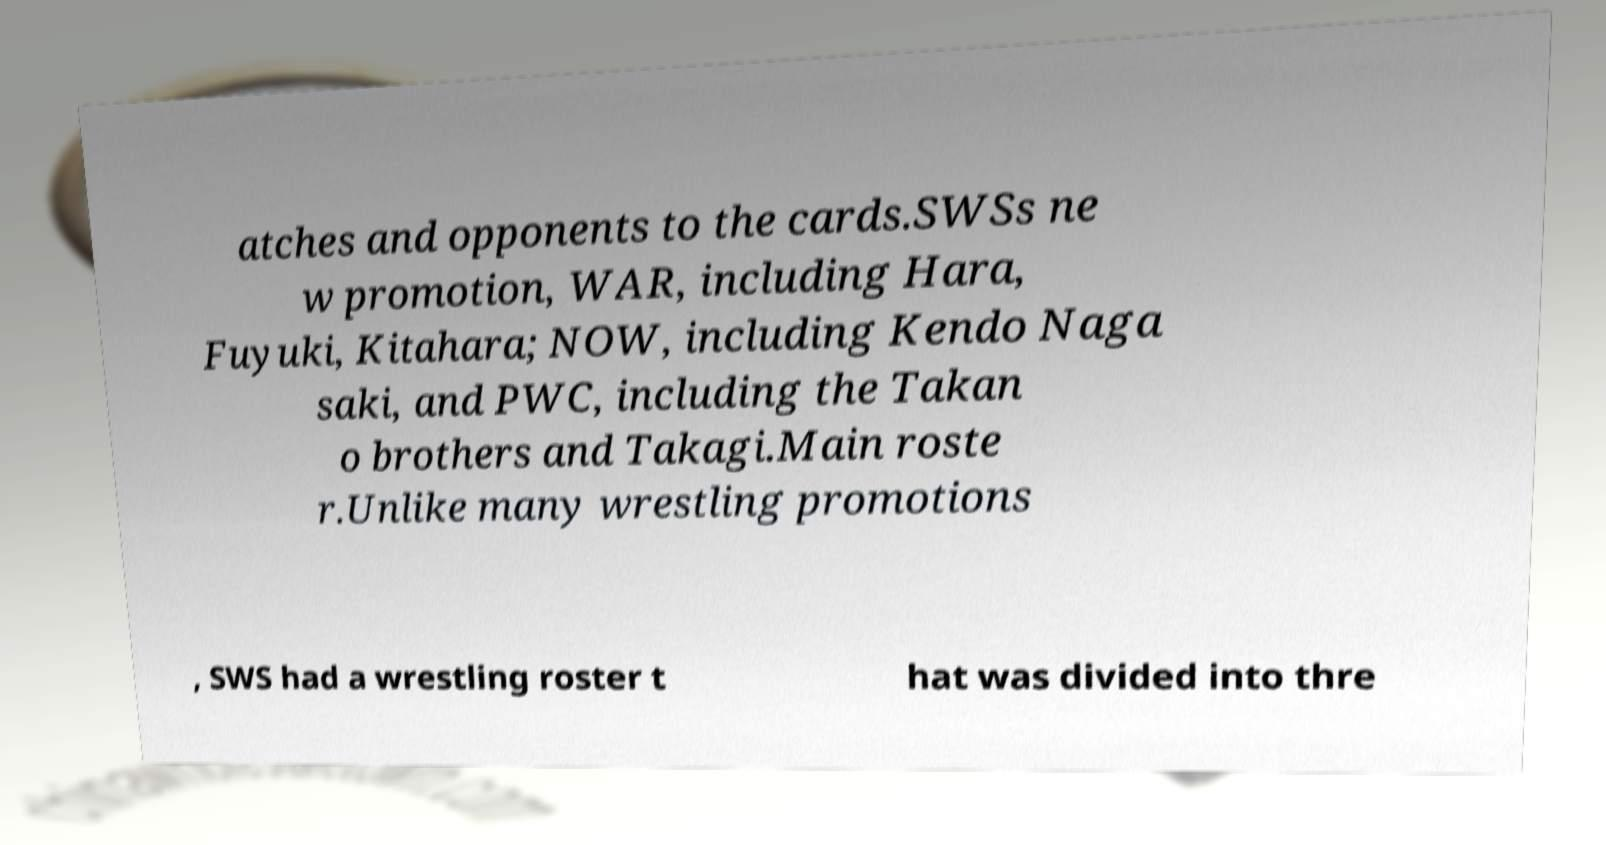Please read and relay the text visible in this image. What does it say? atches and opponents to the cards.SWSs ne w promotion, WAR, including Hara, Fuyuki, Kitahara; NOW, including Kendo Naga saki, and PWC, including the Takan o brothers and Takagi.Main roste r.Unlike many wrestling promotions , SWS had a wrestling roster t hat was divided into thre 